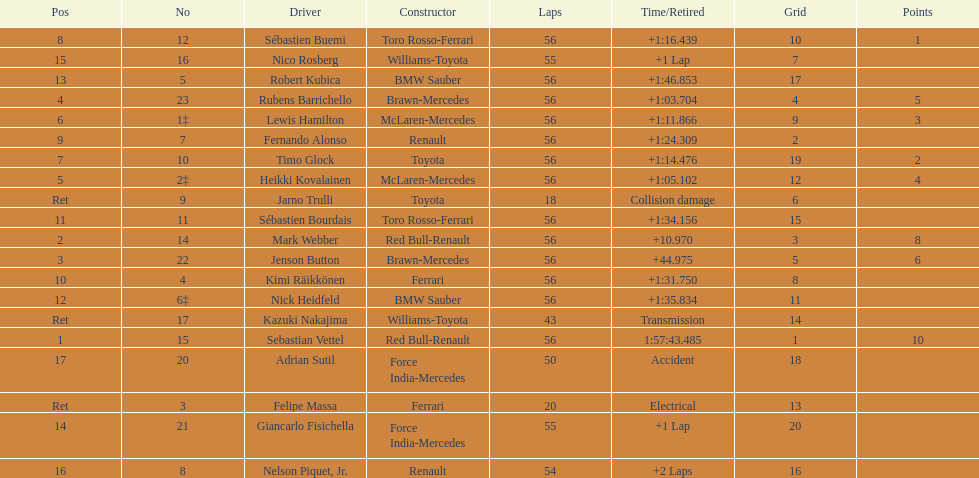I'm looking to parse the entire table for insights. Could you assist me with that? {'header': ['Pos', 'No', 'Driver', 'Constructor', 'Laps', 'Time/Retired', 'Grid', 'Points'], 'rows': [['8', '12', 'Sébastien Buemi', 'Toro Rosso-Ferrari', '56', '+1:16.439', '10', '1'], ['15', '16', 'Nico Rosberg', 'Williams-Toyota', '55', '+1 Lap', '7', ''], ['13', '5', 'Robert Kubica', 'BMW Sauber', '56', '+1:46.853', '17', ''], ['4', '23', 'Rubens Barrichello', 'Brawn-Mercedes', '56', '+1:03.704', '4', '5'], ['6', '1‡', 'Lewis Hamilton', 'McLaren-Mercedes', '56', '+1:11.866', '9', '3'], ['9', '7', 'Fernando Alonso', 'Renault', '56', '+1:24.309', '2', ''], ['7', '10', 'Timo Glock', 'Toyota', '56', '+1:14.476', '19', '2'], ['5', '2‡', 'Heikki Kovalainen', 'McLaren-Mercedes', '56', '+1:05.102', '12', '4'], ['Ret', '9', 'Jarno Trulli', 'Toyota', '18', 'Collision damage', '6', ''], ['11', '11', 'Sébastien Bourdais', 'Toro Rosso-Ferrari', '56', '+1:34.156', '15', ''], ['2', '14', 'Mark Webber', 'Red Bull-Renault', '56', '+10.970', '3', '8'], ['3', '22', 'Jenson Button', 'Brawn-Mercedes', '56', '+44.975', '5', '6'], ['10', '4', 'Kimi Räikkönen', 'Ferrari', '56', '+1:31.750', '8', ''], ['12', '6‡', 'Nick Heidfeld', 'BMW Sauber', '56', '+1:35.834', '11', ''], ['Ret', '17', 'Kazuki Nakajima', 'Williams-Toyota', '43', 'Transmission', '14', ''], ['1', '15', 'Sebastian Vettel', 'Red Bull-Renault', '56', '1:57:43.485', '1', '10'], ['17', '20', 'Adrian Sutil', 'Force India-Mercedes', '50', 'Accident', '18', ''], ['Ret', '3', 'Felipe Massa', 'Ferrari', '20', 'Electrical', '13', ''], ['14', '21', 'Giancarlo Fisichella', 'Force India-Mercedes', '55', '+1 Lap', '20', ''], ['16', '8', 'Nelson Piquet, Jr.', 'Renault', '54', '+2 Laps', '16', '']]} How many laps in total is the race? 56. 